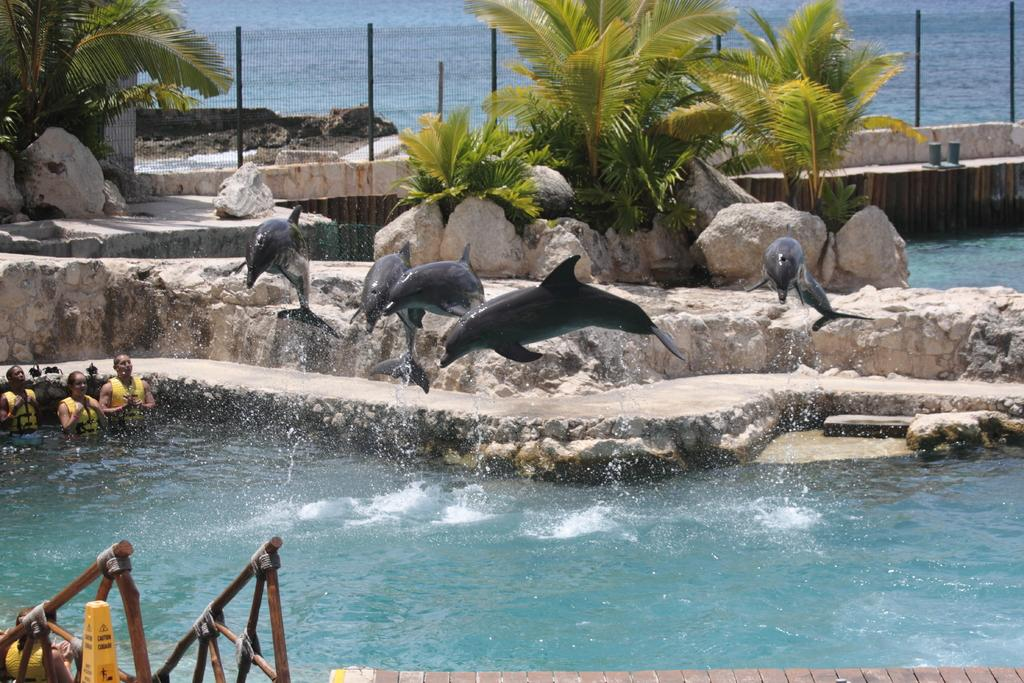What are the persons in the image doing? The persons in the image are in the water. What animals can be seen in the image? Dolphins are jumping into the water in the image. What natural features are visible in the image? There are rocks and trees visible in the image. What man-made structure can be seen in the image? There is a fence in the image. Can you describe any other objects in the image? There are other unspecified objects in the image. How does the image depict the aftermath of a rainstorm? The image does not depict the aftermath of a rainstorm; there is no mention of rain or any related effects in the provided facts. What type of slip can be seen on the rocks in the image? There is no slip visible on the rocks in the image; the rocks are simply part of the natural landscape. 